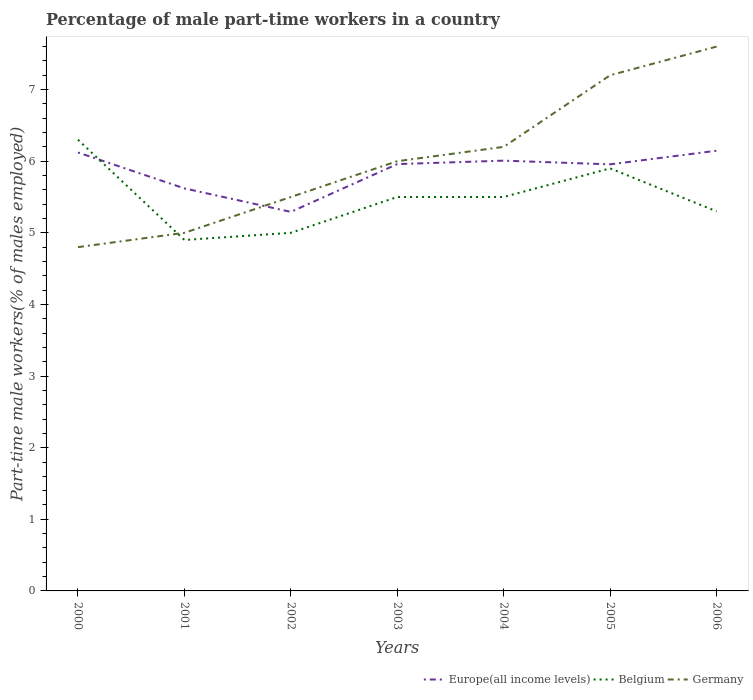How many different coloured lines are there?
Ensure brevity in your answer.  3. Across all years, what is the maximum percentage of male part-time workers in Belgium?
Give a very brief answer. 4.9. What is the total percentage of male part-time workers in Europe(all income levels) in the graph?
Give a very brief answer. 0.17. What is the difference between the highest and the second highest percentage of male part-time workers in Europe(all income levels)?
Your answer should be very brief. 0.85. What is the difference between the highest and the lowest percentage of male part-time workers in Europe(all income levels)?
Provide a succinct answer. 5. How many lines are there?
Make the answer very short. 3. Are the values on the major ticks of Y-axis written in scientific E-notation?
Provide a succinct answer. No. Does the graph contain any zero values?
Provide a short and direct response. No. Does the graph contain grids?
Provide a succinct answer. No. Where does the legend appear in the graph?
Offer a terse response. Bottom right. How many legend labels are there?
Keep it short and to the point. 3. How are the legend labels stacked?
Your answer should be very brief. Horizontal. What is the title of the graph?
Provide a short and direct response. Percentage of male part-time workers in a country. What is the label or title of the Y-axis?
Offer a terse response. Part-time male workers(% of males employed). What is the Part-time male workers(% of males employed) in Europe(all income levels) in 2000?
Your answer should be compact. 6.12. What is the Part-time male workers(% of males employed) of Belgium in 2000?
Give a very brief answer. 6.3. What is the Part-time male workers(% of males employed) in Germany in 2000?
Offer a terse response. 4.8. What is the Part-time male workers(% of males employed) of Europe(all income levels) in 2001?
Offer a terse response. 5.62. What is the Part-time male workers(% of males employed) in Belgium in 2001?
Make the answer very short. 4.9. What is the Part-time male workers(% of males employed) in Germany in 2001?
Your answer should be compact. 5. What is the Part-time male workers(% of males employed) in Europe(all income levels) in 2002?
Your answer should be compact. 5.29. What is the Part-time male workers(% of males employed) of Europe(all income levels) in 2003?
Provide a succinct answer. 5.96. What is the Part-time male workers(% of males employed) of Europe(all income levels) in 2004?
Make the answer very short. 6.01. What is the Part-time male workers(% of males employed) of Germany in 2004?
Give a very brief answer. 6.2. What is the Part-time male workers(% of males employed) in Europe(all income levels) in 2005?
Provide a short and direct response. 5.96. What is the Part-time male workers(% of males employed) of Belgium in 2005?
Give a very brief answer. 5.9. What is the Part-time male workers(% of males employed) in Germany in 2005?
Ensure brevity in your answer.  7.2. What is the Part-time male workers(% of males employed) in Europe(all income levels) in 2006?
Provide a short and direct response. 6.15. What is the Part-time male workers(% of males employed) in Belgium in 2006?
Offer a terse response. 5.3. What is the Part-time male workers(% of males employed) of Germany in 2006?
Ensure brevity in your answer.  7.6. Across all years, what is the maximum Part-time male workers(% of males employed) in Europe(all income levels)?
Provide a short and direct response. 6.15. Across all years, what is the maximum Part-time male workers(% of males employed) in Belgium?
Make the answer very short. 6.3. Across all years, what is the maximum Part-time male workers(% of males employed) in Germany?
Your answer should be very brief. 7.6. Across all years, what is the minimum Part-time male workers(% of males employed) in Europe(all income levels)?
Your answer should be compact. 5.29. Across all years, what is the minimum Part-time male workers(% of males employed) of Belgium?
Keep it short and to the point. 4.9. Across all years, what is the minimum Part-time male workers(% of males employed) in Germany?
Your response must be concise. 4.8. What is the total Part-time male workers(% of males employed) of Europe(all income levels) in the graph?
Offer a very short reply. 41.1. What is the total Part-time male workers(% of males employed) of Belgium in the graph?
Your response must be concise. 38.4. What is the total Part-time male workers(% of males employed) of Germany in the graph?
Your answer should be compact. 42.3. What is the difference between the Part-time male workers(% of males employed) of Europe(all income levels) in 2000 and that in 2001?
Offer a terse response. 0.5. What is the difference between the Part-time male workers(% of males employed) in Belgium in 2000 and that in 2001?
Give a very brief answer. 1.4. What is the difference between the Part-time male workers(% of males employed) of Europe(all income levels) in 2000 and that in 2002?
Make the answer very short. 0.83. What is the difference between the Part-time male workers(% of males employed) of Belgium in 2000 and that in 2002?
Provide a succinct answer. 1.3. What is the difference between the Part-time male workers(% of males employed) in Germany in 2000 and that in 2002?
Your response must be concise. -0.7. What is the difference between the Part-time male workers(% of males employed) of Europe(all income levels) in 2000 and that in 2003?
Provide a succinct answer. 0.16. What is the difference between the Part-time male workers(% of males employed) of Belgium in 2000 and that in 2003?
Make the answer very short. 0.8. What is the difference between the Part-time male workers(% of males employed) in Europe(all income levels) in 2000 and that in 2004?
Offer a terse response. 0.11. What is the difference between the Part-time male workers(% of males employed) of Europe(all income levels) in 2000 and that in 2005?
Your answer should be compact. 0.17. What is the difference between the Part-time male workers(% of males employed) in Belgium in 2000 and that in 2005?
Provide a short and direct response. 0.4. What is the difference between the Part-time male workers(% of males employed) of Germany in 2000 and that in 2005?
Make the answer very short. -2.4. What is the difference between the Part-time male workers(% of males employed) of Europe(all income levels) in 2000 and that in 2006?
Provide a short and direct response. -0.02. What is the difference between the Part-time male workers(% of males employed) in Germany in 2000 and that in 2006?
Ensure brevity in your answer.  -2.8. What is the difference between the Part-time male workers(% of males employed) in Europe(all income levels) in 2001 and that in 2002?
Provide a succinct answer. 0.33. What is the difference between the Part-time male workers(% of males employed) in Belgium in 2001 and that in 2002?
Provide a short and direct response. -0.1. What is the difference between the Part-time male workers(% of males employed) of Germany in 2001 and that in 2002?
Your answer should be very brief. -0.5. What is the difference between the Part-time male workers(% of males employed) of Europe(all income levels) in 2001 and that in 2003?
Offer a very short reply. -0.34. What is the difference between the Part-time male workers(% of males employed) in Belgium in 2001 and that in 2003?
Make the answer very short. -0.6. What is the difference between the Part-time male workers(% of males employed) of Europe(all income levels) in 2001 and that in 2004?
Give a very brief answer. -0.39. What is the difference between the Part-time male workers(% of males employed) of Belgium in 2001 and that in 2004?
Your answer should be compact. -0.6. What is the difference between the Part-time male workers(% of males employed) of Europe(all income levels) in 2001 and that in 2005?
Keep it short and to the point. -0.34. What is the difference between the Part-time male workers(% of males employed) in Belgium in 2001 and that in 2005?
Ensure brevity in your answer.  -1. What is the difference between the Part-time male workers(% of males employed) of Europe(all income levels) in 2001 and that in 2006?
Provide a succinct answer. -0.53. What is the difference between the Part-time male workers(% of males employed) in Europe(all income levels) in 2002 and that in 2003?
Provide a short and direct response. -0.67. What is the difference between the Part-time male workers(% of males employed) in Germany in 2002 and that in 2003?
Your response must be concise. -0.5. What is the difference between the Part-time male workers(% of males employed) in Europe(all income levels) in 2002 and that in 2004?
Ensure brevity in your answer.  -0.72. What is the difference between the Part-time male workers(% of males employed) in Belgium in 2002 and that in 2004?
Give a very brief answer. -0.5. What is the difference between the Part-time male workers(% of males employed) of Germany in 2002 and that in 2004?
Provide a succinct answer. -0.7. What is the difference between the Part-time male workers(% of males employed) in Europe(all income levels) in 2002 and that in 2005?
Ensure brevity in your answer.  -0.66. What is the difference between the Part-time male workers(% of males employed) in Belgium in 2002 and that in 2005?
Your response must be concise. -0.9. What is the difference between the Part-time male workers(% of males employed) in Europe(all income levels) in 2002 and that in 2006?
Give a very brief answer. -0.85. What is the difference between the Part-time male workers(% of males employed) of Germany in 2002 and that in 2006?
Your answer should be very brief. -2.1. What is the difference between the Part-time male workers(% of males employed) of Europe(all income levels) in 2003 and that in 2004?
Offer a terse response. -0.05. What is the difference between the Part-time male workers(% of males employed) in Belgium in 2003 and that in 2004?
Give a very brief answer. 0. What is the difference between the Part-time male workers(% of males employed) of Europe(all income levels) in 2003 and that in 2005?
Make the answer very short. 0. What is the difference between the Part-time male workers(% of males employed) of Europe(all income levels) in 2003 and that in 2006?
Ensure brevity in your answer.  -0.19. What is the difference between the Part-time male workers(% of males employed) in Belgium in 2003 and that in 2006?
Make the answer very short. 0.2. What is the difference between the Part-time male workers(% of males employed) in Europe(all income levels) in 2004 and that in 2005?
Give a very brief answer. 0.05. What is the difference between the Part-time male workers(% of males employed) in Belgium in 2004 and that in 2005?
Give a very brief answer. -0.4. What is the difference between the Part-time male workers(% of males employed) in Germany in 2004 and that in 2005?
Offer a terse response. -1. What is the difference between the Part-time male workers(% of males employed) in Europe(all income levels) in 2004 and that in 2006?
Your response must be concise. -0.14. What is the difference between the Part-time male workers(% of males employed) in Germany in 2004 and that in 2006?
Ensure brevity in your answer.  -1.4. What is the difference between the Part-time male workers(% of males employed) in Europe(all income levels) in 2005 and that in 2006?
Ensure brevity in your answer.  -0.19. What is the difference between the Part-time male workers(% of males employed) of Belgium in 2005 and that in 2006?
Your response must be concise. 0.6. What is the difference between the Part-time male workers(% of males employed) in Europe(all income levels) in 2000 and the Part-time male workers(% of males employed) in Belgium in 2001?
Provide a short and direct response. 1.22. What is the difference between the Part-time male workers(% of males employed) in Europe(all income levels) in 2000 and the Part-time male workers(% of males employed) in Germany in 2001?
Make the answer very short. 1.12. What is the difference between the Part-time male workers(% of males employed) in Europe(all income levels) in 2000 and the Part-time male workers(% of males employed) in Belgium in 2002?
Keep it short and to the point. 1.12. What is the difference between the Part-time male workers(% of males employed) of Europe(all income levels) in 2000 and the Part-time male workers(% of males employed) of Germany in 2002?
Provide a succinct answer. 0.62. What is the difference between the Part-time male workers(% of males employed) of Europe(all income levels) in 2000 and the Part-time male workers(% of males employed) of Belgium in 2003?
Your answer should be compact. 0.62. What is the difference between the Part-time male workers(% of males employed) in Europe(all income levels) in 2000 and the Part-time male workers(% of males employed) in Germany in 2003?
Offer a terse response. 0.12. What is the difference between the Part-time male workers(% of males employed) of Belgium in 2000 and the Part-time male workers(% of males employed) of Germany in 2003?
Your answer should be very brief. 0.3. What is the difference between the Part-time male workers(% of males employed) in Europe(all income levels) in 2000 and the Part-time male workers(% of males employed) in Belgium in 2004?
Give a very brief answer. 0.62. What is the difference between the Part-time male workers(% of males employed) of Europe(all income levels) in 2000 and the Part-time male workers(% of males employed) of Germany in 2004?
Your answer should be compact. -0.08. What is the difference between the Part-time male workers(% of males employed) of Belgium in 2000 and the Part-time male workers(% of males employed) of Germany in 2004?
Provide a short and direct response. 0.1. What is the difference between the Part-time male workers(% of males employed) of Europe(all income levels) in 2000 and the Part-time male workers(% of males employed) of Belgium in 2005?
Offer a terse response. 0.22. What is the difference between the Part-time male workers(% of males employed) in Europe(all income levels) in 2000 and the Part-time male workers(% of males employed) in Germany in 2005?
Keep it short and to the point. -1.08. What is the difference between the Part-time male workers(% of males employed) in Belgium in 2000 and the Part-time male workers(% of males employed) in Germany in 2005?
Offer a terse response. -0.9. What is the difference between the Part-time male workers(% of males employed) in Europe(all income levels) in 2000 and the Part-time male workers(% of males employed) in Belgium in 2006?
Make the answer very short. 0.82. What is the difference between the Part-time male workers(% of males employed) of Europe(all income levels) in 2000 and the Part-time male workers(% of males employed) of Germany in 2006?
Provide a succinct answer. -1.48. What is the difference between the Part-time male workers(% of males employed) of Europe(all income levels) in 2001 and the Part-time male workers(% of males employed) of Belgium in 2002?
Offer a very short reply. 0.62. What is the difference between the Part-time male workers(% of males employed) of Europe(all income levels) in 2001 and the Part-time male workers(% of males employed) of Germany in 2002?
Offer a terse response. 0.12. What is the difference between the Part-time male workers(% of males employed) in Belgium in 2001 and the Part-time male workers(% of males employed) in Germany in 2002?
Your response must be concise. -0.6. What is the difference between the Part-time male workers(% of males employed) in Europe(all income levels) in 2001 and the Part-time male workers(% of males employed) in Belgium in 2003?
Ensure brevity in your answer.  0.12. What is the difference between the Part-time male workers(% of males employed) in Europe(all income levels) in 2001 and the Part-time male workers(% of males employed) in Germany in 2003?
Your answer should be very brief. -0.38. What is the difference between the Part-time male workers(% of males employed) of Belgium in 2001 and the Part-time male workers(% of males employed) of Germany in 2003?
Offer a terse response. -1.1. What is the difference between the Part-time male workers(% of males employed) of Europe(all income levels) in 2001 and the Part-time male workers(% of males employed) of Belgium in 2004?
Provide a short and direct response. 0.12. What is the difference between the Part-time male workers(% of males employed) of Europe(all income levels) in 2001 and the Part-time male workers(% of males employed) of Germany in 2004?
Provide a succinct answer. -0.58. What is the difference between the Part-time male workers(% of males employed) in Europe(all income levels) in 2001 and the Part-time male workers(% of males employed) in Belgium in 2005?
Keep it short and to the point. -0.28. What is the difference between the Part-time male workers(% of males employed) of Europe(all income levels) in 2001 and the Part-time male workers(% of males employed) of Germany in 2005?
Your answer should be very brief. -1.58. What is the difference between the Part-time male workers(% of males employed) of Europe(all income levels) in 2001 and the Part-time male workers(% of males employed) of Belgium in 2006?
Offer a terse response. 0.32. What is the difference between the Part-time male workers(% of males employed) of Europe(all income levels) in 2001 and the Part-time male workers(% of males employed) of Germany in 2006?
Keep it short and to the point. -1.98. What is the difference between the Part-time male workers(% of males employed) in Europe(all income levels) in 2002 and the Part-time male workers(% of males employed) in Belgium in 2003?
Provide a succinct answer. -0.21. What is the difference between the Part-time male workers(% of males employed) of Europe(all income levels) in 2002 and the Part-time male workers(% of males employed) of Germany in 2003?
Provide a succinct answer. -0.71. What is the difference between the Part-time male workers(% of males employed) of Europe(all income levels) in 2002 and the Part-time male workers(% of males employed) of Belgium in 2004?
Ensure brevity in your answer.  -0.21. What is the difference between the Part-time male workers(% of males employed) in Europe(all income levels) in 2002 and the Part-time male workers(% of males employed) in Germany in 2004?
Make the answer very short. -0.91. What is the difference between the Part-time male workers(% of males employed) of Europe(all income levels) in 2002 and the Part-time male workers(% of males employed) of Belgium in 2005?
Provide a short and direct response. -0.61. What is the difference between the Part-time male workers(% of males employed) of Europe(all income levels) in 2002 and the Part-time male workers(% of males employed) of Germany in 2005?
Provide a succinct answer. -1.91. What is the difference between the Part-time male workers(% of males employed) in Europe(all income levels) in 2002 and the Part-time male workers(% of males employed) in Belgium in 2006?
Ensure brevity in your answer.  -0.01. What is the difference between the Part-time male workers(% of males employed) in Europe(all income levels) in 2002 and the Part-time male workers(% of males employed) in Germany in 2006?
Your answer should be very brief. -2.31. What is the difference between the Part-time male workers(% of males employed) of Belgium in 2002 and the Part-time male workers(% of males employed) of Germany in 2006?
Keep it short and to the point. -2.6. What is the difference between the Part-time male workers(% of males employed) of Europe(all income levels) in 2003 and the Part-time male workers(% of males employed) of Belgium in 2004?
Give a very brief answer. 0.46. What is the difference between the Part-time male workers(% of males employed) of Europe(all income levels) in 2003 and the Part-time male workers(% of males employed) of Germany in 2004?
Offer a terse response. -0.24. What is the difference between the Part-time male workers(% of males employed) in Europe(all income levels) in 2003 and the Part-time male workers(% of males employed) in Belgium in 2005?
Give a very brief answer. 0.06. What is the difference between the Part-time male workers(% of males employed) of Europe(all income levels) in 2003 and the Part-time male workers(% of males employed) of Germany in 2005?
Ensure brevity in your answer.  -1.24. What is the difference between the Part-time male workers(% of males employed) of Europe(all income levels) in 2003 and the Part-time male workers(% of males employed) of Belgium in 2006?
Keep it short and to the point. 0.66. What is the difference between the Part-time male workers(% of males employed) in Europe(all income levels) in 2003 and the Part-time male workers(% of males employed) in Germany in 2006?
Offer a very short reply. -1.64. What is the difference between the Part-time male workers(% of males employed) of Europe(all income levels) in 2004 and the Part-time male workers(% of males employed) of Belgium in 2005?
Make the answer very short. 0.11. What is the difference between the Part-time male workers(% of males employed) of Europe(all income levels) in 2004 and the Part-time male workers(% of males employed) of Germany in 2005?
Give a very brief answer. -1.19. What is the difference between the Part-time male workers(% of males employed) of Belgium in 2004 and the Part-time male workers(% of males employed) of Germany in 2005?
Offer a terse response. -1.7. What is the difference between the Part-time male workers(% of males employed) in Europe(all income levels) in 2004 and the Part-time male workers(% of males employed) in Belgium in 2006?
Make the answer very short. 0.71. What is the difference between the Part-time male workers(% of males employed) of Europe(all income levels) in 2004 and the Part-time male workers(% of males employed) of Germany in 2006?
Your answer should be very brief. -1.59. What is the difference between the Part-time male workers(% of males employed) of Belgium in 2004 and the Part-time male workers(% of males employed) of Germany in 2006?
Give a very brief answer. -2.1. What is the difference between the Part-time male workers(% of males employed) of Europe(all income levels) in 2005 and the Part-time male workers(% of males employed) of Belgium in 2006?
Your answer should be compact. 0.66. What is the difference between the Part-time male workers(% of males employed) of Europe(all income levels) in 2005 and the Part-time male workers(% of males employed) of Germany in 2006?
Keep it short and to the point. -1.64. What is the average Part-time male workers(% of males employed) of Europe(all income levels) per year?
Your answer should be compact. 5.87. What is the average Part-time male workers(% of males employed) of Belgium per year?
Give a very brief answer. 5.49. What is the average Part-time male workers(% of males employed) in Germany per year?
Keep it short and to the point. 6.04. In the year 2000, what is the difference between the Part-time male workers(% of males employed) of Europe(all income levels) and Part-time male workers(% of males employed) of Belgium?
Keep it short and to the point. -0.18. In the year 2000, what is the difference between the Part-time male workers(% of males employed) of Europe(all income levels) and Part-time male workers(% of males employed) of Germany?
Provide a short and direct response. 1.32. In the year 2000, what is the difference between the Part-time male workers(% of males employed) in Belgium and Part-time male workers(% of males employed) in Germany?
Ensure brevity in your answer.  1.5. In the year 2001, what is the difference between the Part-time male workers(% of males employed) in Europe(all income levels) and Part-time male workers(% of males employed) in Belgium?
Ensure brevity in your answer.  0.72. In the year 2001, what is the difference between the Part-time male workers(% of males employed) in Europe(all income levels) and Part-time male workers(% of males employed) in Germany?
Provide a short and direct response. 0.62. In the year 2001, what is the difference between the Part-time male workers(% of males employed) of Belgium and Part-time male workers(% of males employed) of Germany?
Your response must be concise. -0.1. In the year 2002, what is the difference between the Part-time male workers(% of males employed) of Europe(all income levels) and Part-time male workers(% of males employed) of Belgium?
Provide a short and direct response. 0.29. In the year 2002, what is the difference between the Part-time male workers(% of males employed) in Europe(all income levels) and Part-time male workers(% of males employed) in Germany?
Your answer should be very brief. -0.21. In the year 2002, what is the difference between the Part-time male workers(% of males employed) in Belgium and Part-time male workers(% of males employed) in Germany?
Keep it short and to the point. -0.5. In the year 2003, what is the difference between the Part-time male workers(% of males employed) in Europe(all income levels) and Part-time male workers(% of males employed) in Belgium?
Your answer should be compact. 0.46. In the year 2003, what is the difference between the Part-time male workers(% of males employed) of Europe(all income levels) and Part-time male workers(% of males employed) of Germany?
Keep it short and to the point. -0.04. In the year 2003, what is the difference between the Part-time male workers(% of males employed) of Belgium and Part-time male workers(% of males employed) of Germany?
Ensure brevity in your answer.  -0.5. In the year 2004, what is the difference between the Part-time male workers(% of males employed) in Europe(all income levels) and Part-time male workers(% of males employed) in Belgium?
Ensure brevity in your answer.  0.51. In the year 2004, what is the difference between the Part-time male workers(% of males employed) in Europe(all income levels) and Part-time male workers(% of males employed) in Germany?
Make the answer very short. -0.19. In the year 2004, what is the difference between the Part-time male workers(% of males employed) in Belgium and Part-time male workers(% of males employed) in Germany?
Offer a terse response. -0.7. In the year 2005, what is the difference between the Part-time male workers(% of males employed) in Europe(all income levels) and Part-time male workers(% of males employed) in Belgium?
Provide a succinct answer. 0.06. In the year 2005, what is the difference between the Part-time male workers(% of males employed) of Europe(all income levels) and Part-time male workers(% of males employed) of Germany?
Give a very brief answer. -1.24. In the year 2005, what is the difference between the Part-time male workers(% of males employed) in Belgium and Part-time male workers(% of males employed) in Germany?
Offer a terse response. -1.3. In the year 2006, what is the difference between the Part-time male workers(% of males employed) in Europe(all income levels) and Part-time male workers(% of males employed) in Belgium?
Offer a terse response. 0.85. In the year 2006, what is the difference between the Part-time male workers(% of males employed) of Europe(all income levels) and Part-time male workers(% of males employed) of Germany?
Offer a terse response. -1.45. In the year 2006, what is the difference between the Part-time male workers(% of males employed) of Belgium and Part-time male workers(% of males employed) of Germany?
Your response must be concise. -2.3. What is the ratio of the Part-time male workers(% of males employed) of Europe(all income levels) in 2000 to that in 2001?
Keep it short and to the point. 1.09. What is the ratio of the Part-time male workers(% of males employed) in Belgium in 2000 to that in 2001?
Keep it short and to the point. 1.29. What is the ratio of the Part-time male workers(% of males employed) of Germany in 2000 to that in 2001?
Provide a short and direct response. 0.96. What is the ratio of the Part-time male workers(% of males employed) of Europe(all income levels) in 2000 to that in 2002?
Offer a very short reply. 1.16. What is the ratio of the Part-time male workers(% of males employed) of Belgium in 2000 to that in 2002?
Make the answer very short. 1.26. What is the ratio of the Part-time male workers(% of males employed) of Germany in 2000 to that in 2002?
Offer a very short reply. 0.87. What is the ratio of the Part-time male workers(% of males employed) of Europe(all income levels) in 2000 to that in 2003?
Your answer should be compact. 1.03. What is the ratio of the Part-time male workers(% of males employed) of Belgium in 2000 to that in 2003?
Give a very brief answer. 1.15. What is the ratio of the Part-time male workers(% of males employed) in Germany in 2000 to that in 2003?
Ensure brevity in your answer.  0.8. What is the ratio of the Part-time male workers(% of males employed) in Belgium in 2000 to that in 2004?
Ensure brevity in your answer.  1.15. What is the ratio of the Part-time male workers(% of males employed) of Germany in 2000 to that in 2004?
Ensure brevity in your answer.  0.77. What is the ratio of the Part-time male workers(% of males employed) in Europe(all income levels) in 2000 to that in 2005?
Your response must be concise. 1.03. What is the ratio of the Part-time male workers(% of males employed) in Belgium in 2000 to that in 2005?
Your answer should be compact. 1.07. What is the ratio of the Part-time male workers(% of males employed) in Belgium in 2000 to that in 2006?
Your answer should be very brief. 1.19. What is the ratio of the Part-time male workers(% of males employed) in Germany in 2000 to that in 2006?
Your response must be concise. 0.63. What is the ratio of the Part-time male workers(% of males employed) in Europe(all income levels) in 2001 to that in 2002?
Your response must be concise. 1.06. What is the ratio of the Part-time male workers(% of males employed) of Germany in 2001 to that in 2002?
Your response must be concise. 0.91. What is the ratio of the Part-time male workers(% of males employed) of Europe(all income levels) in 2001 to that in 2003?
Keep it short and to the point. 0.94. What is the ratio of the Part-time male workers(% of males employed) of Belgium in 2001 to that in 2003?
Provide a short and direct response. 0.89. What is the ratio of the Part-time male workers(% of males employed) in Germany in 2001 to that in 2003?
Provide a succinct answer. 0.83. What is the ratio of the Part-time male workers(% of males employed) of Europe(all income levels) in 2001 to that in 2004?
Keep it short and to the point. 0.94. What is the ratio of the Part-time male workers(% of males employed) in Belgium in 2001 to that in 2004?
Your answer should be very brief. 0.89. What is the ratio of the Part-time male workers(% of males employed) in Germany in 2001 to that in 2004?
Offer a very short reply. 0.81. What is the ratio of the Part-time male workers(% of males employed) of Europe(all income levels) in 2001 to that in 2005?
Ensure brevity in your answer.  0.94. What is the ratio of the Part-time male workers(% of males employed) of Belgium in 2001 to that in 2005?
Make the answer very short. 0.83. What is the ratio of the Part-time male workers(% of males employed) in Germany in 2001 to that in 2005?
Ensure brevity in your answer.  0.69. What is the ratio of the Part-time male workers(% of males employed) in Europe(all income levels) in 2001 to that in 2006?
Offer a terse response. 0.91. What is the ratio of the Part-time male workers(% of males employed) of Belgium in 2001 to that in 2006?
Your answer should be compact. 0.92. What is the ratio of the Part-time male workers(% of males employed) in Germany in 2001 to that in 2006?
Ensure brevity in your answer.  0.66. What is the ratio of the Part-time male workers(% of males employed) in Europe(all income levels) in 2002 to that in 2003?
Make the answer very short. 0.89. What is the ratio of the Part-time male workers(% of males employed) in Belgium in 2002 to that in 2003?
Offer a terse response. 0.91. What is the ratio of the Part-time male workers(% of males employed) in Europe(all income levels) in 2002 to that in 2004?
Make the answer very short. 0.88. What is the ratio of the Part-time male workers(% of males employed) of Germany in 2002 to that in 2004?
Your response must be concise. 0.89. What is the ratio of the Part-time male workers(% of males employed) of Europe(all income levels) in 2002 to that in 2005?
Provide a succinct answer. 0.89. What is the ratio of the Part-time male workers(% of males employed) of Belgium in 2002 to that in 2005?
Your answer should be very brief. 0.85. What is the ratio of the Part-time male workers(% of males employed) in Germany in 2002 to that in 2005?
Offer a very short reply. 0.76. What is the ratio of the Part-time male workers(% of males employed) in Europe(all income levels) in 2002 to that in 2006?
Your response must be concise. 0.86. What is the ratio of the Part-time male workers(% of males employed) of Belgium in 2002 to that in 2006?
Your answer should be very brief. 0.94. What is the ratio of the Part-time male workers(% of males employed) in Germany in 2002 to that in 2006?
Your response must be concise. 0.72. What is the ratio of the Part-time male workers(% of males employed) in Europe(all income levels) in 2003 to that in 2004?
Offer a very short reply. 0.99. What is the ratio of the Part-time male workers(% of males employed) of Belgium in 2003 to that in 2005?
Make the answer very short. 0.93. What is the ratio of the Part-time male workers(% of males employed) of Europe(all income levels) in 2003 to that in 2006?
Your answer should be compact. 0.97. What is the ratio of the Part-time male workers(% of males employed) of Belgium in 2003 to that in 2006?
Your answer should be compact. 1.04. What is the ratio of the Part-time male workers(% of males employed) of Germany in 2003 to that in 2006?
Offer a terse response. 0.79. What is the ratio of the Part-time male workers(% of males employed) in Europe(all income levels) in 2004 to that in 2005?
Your answer should be very brief. 1.01. What is the ratio of the Part-time male workers(% of males employed) of Belgium in 2004 to that in 2005?
Give a very brief answer. 0.93. What is the ratio of the Part-time male workers(% of males employed) of Germany in 2004 to that in 2005?
Keep it short and to the point. 0.86. What is the ratio of the Part-time male workers(% of males employed) in Europe(all income levels) in 2004 to that in 2006?
Offer a terse response. 0.98. What is the ratio of the Part-time male workers(% of males employed) of Belgium in 2004 to that in 2006?
Provide a succinct answer. 1.04. What is the ratio of the Part-time male workers(% of males employed) in Germany in 2004 to that in 2006?
Keep it short and to the point. 0.82. What is the ratio of the Part-time male workers(% of males employed) of Europe(all income levels) in 2005 to that in 2006?
Offer a very short reply. 0.97. What is the ratio of the Part-time male workers(% of males employed) in Belgium in 2005 to that in 2006?
Your answer should be very brief. 1.11. What is the difference between the highest and the second highest Part-time male workers(% of males employed) in Europe(all income levels)?
Your response must be concise. 0.02. What is the difference between the highest and the second highest Part-time male workers(% of males employed) of Germany?
Your answer should be very brief. 0.4. What is the difference between the highest and the lowest Part-time male workers(% of males employed) in Europe(all income levels)?
Offer a very short reply. 0.85. What is the difference between the highest and the lowest Part-time male workers(% of males employed) in Belgium?
Offer a terse response. 1.4. 